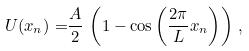Convert formula to latex. <formula><loc_0><loc_0><loc_500><loc_500>U ( x _ { n } ) = & \frac { A } { 2 } \, \left ( 1 - \cos \left ( \frac { 2 \pi } { L } x _ { n } \right ) \right ) \, ,</formula> 